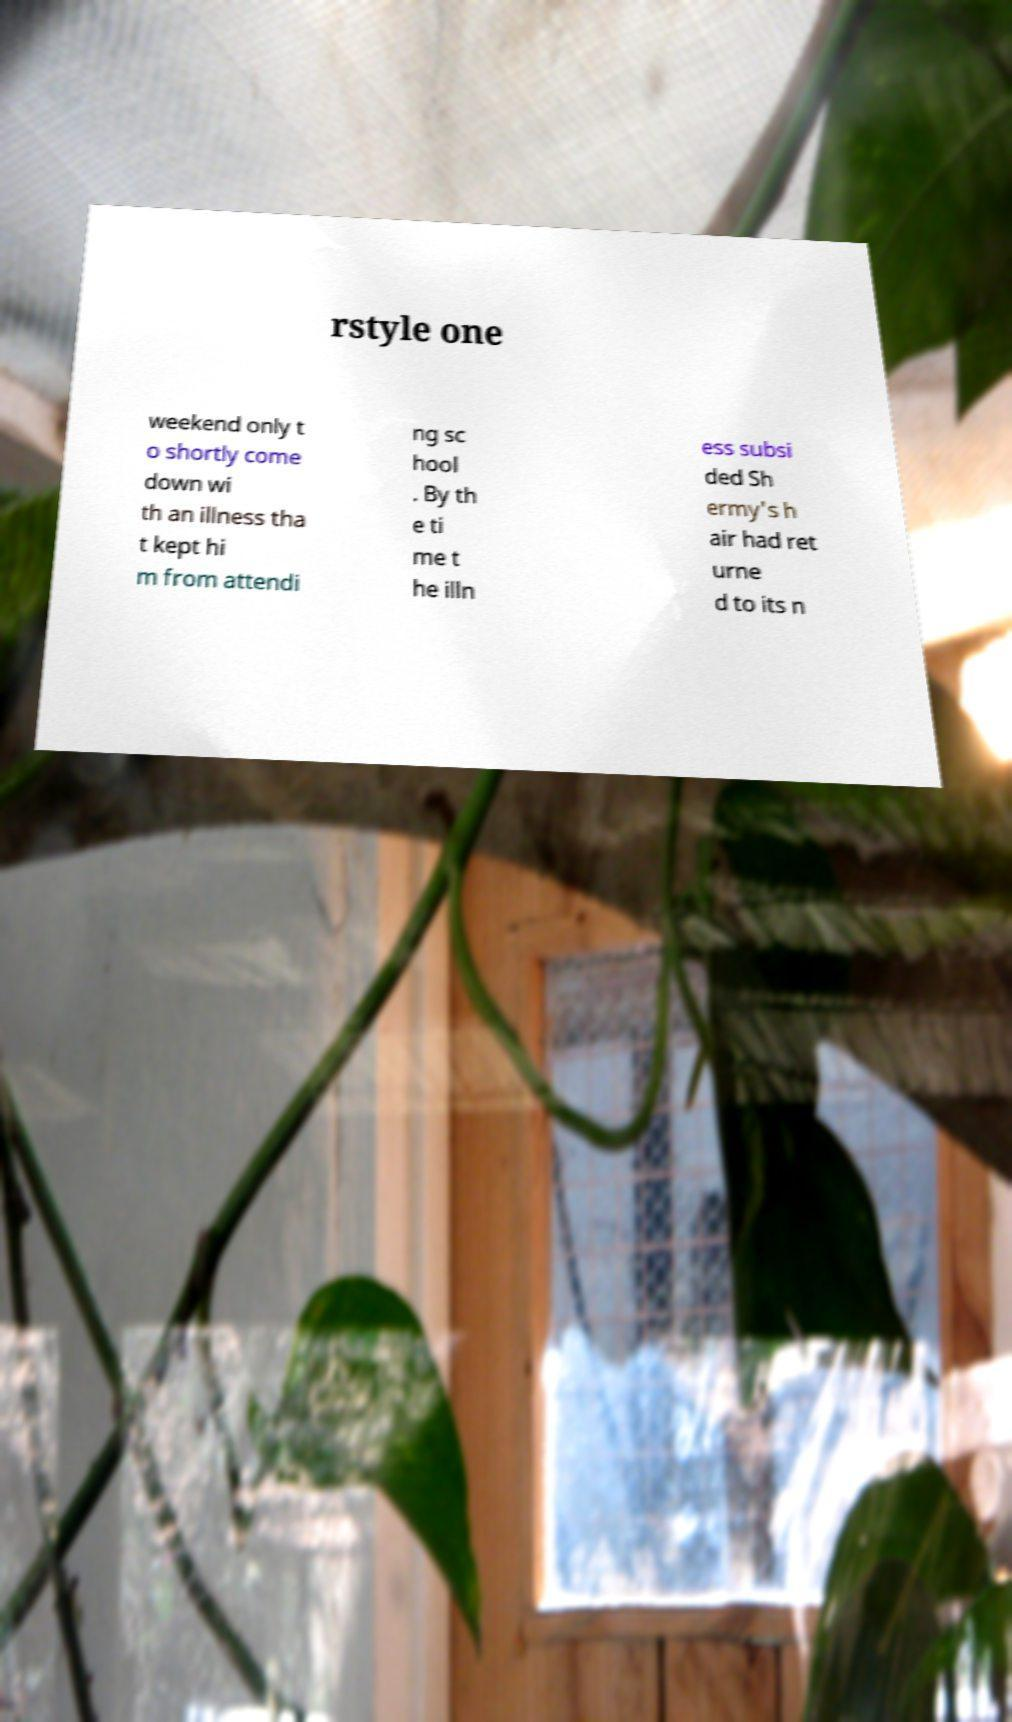For documentation purposes, I need the text within this image transcribed. Could you provide that? rstyle one weekend only t o shortly come down wi th an illness tha t kept hi m from attendi ng sc hool . By th e ti me t he illn ess subsi ded Sh ermy's h air had ret urne d to its n 